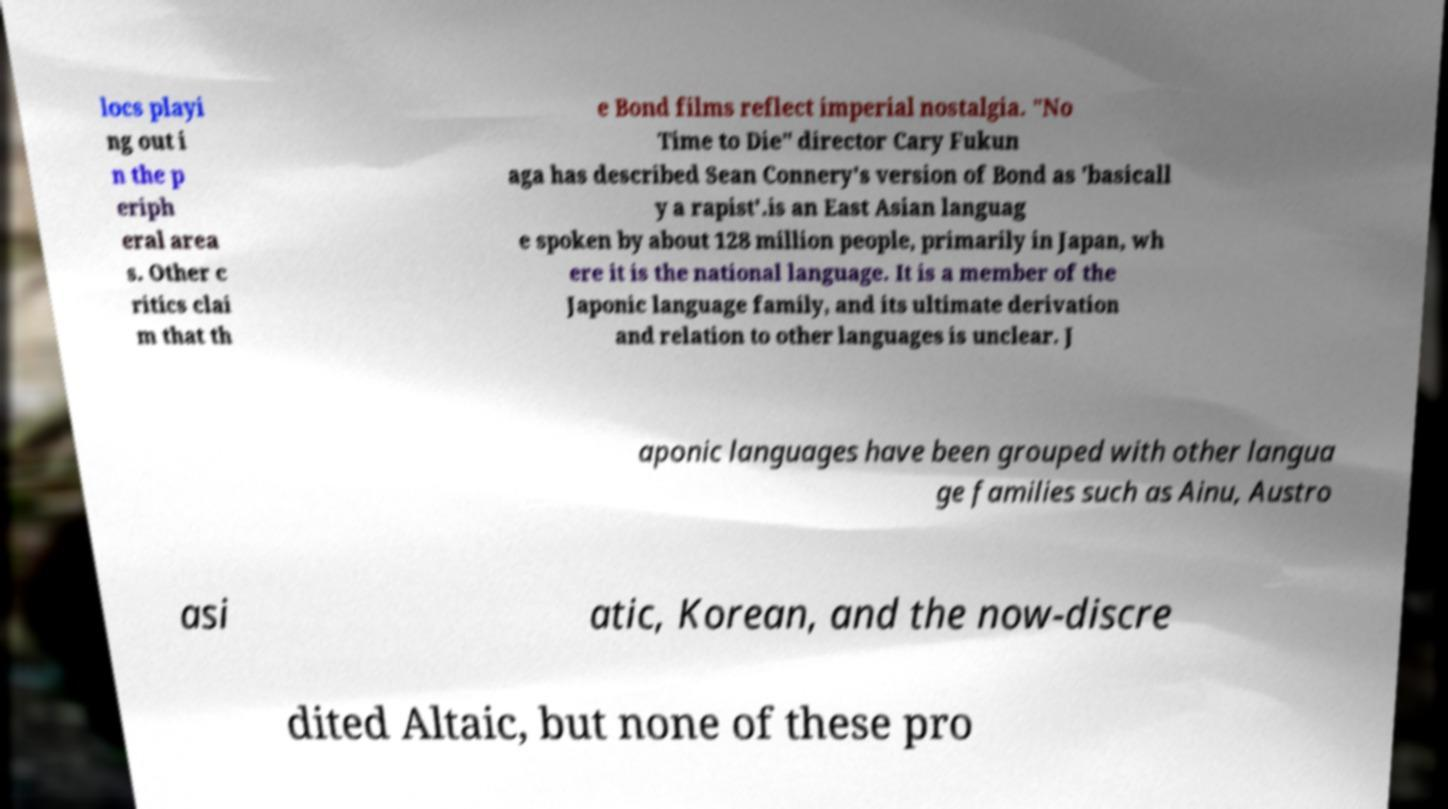Can you read and provide the text displayed in the image?This photo seems to have some interesting text. Can you extract and type it out for me? locs playi ng out i n the p eriph eral area s. Other c ritics clai m that th e Bond films reflect imperial nostalgia. "No Time to Die" director Cary Fukun aga has described Sean Connery's version of Bond as 'basicall y a rapist'.is an East Asian languag e spoken by about 128 million people, primarily in Japan, wh ere it is the national language. It is a member of the Japonic language family, and its ultimate derivation and relation to other languages is unclear. J aponic languages have been grouped with other langua ge families such as Ainu, Austro asi atic, Korean, and the now-discre dited Altaic, but none of these pro 